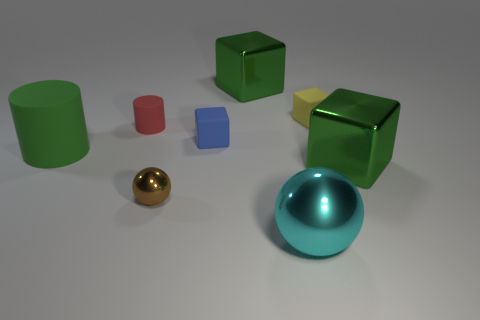There is a large green cube left of the big cube that is in front of the large green metallic object on the left side of the large sphere; what is its material?
Keep it short and to the point. Metal. There is a green cylinder; is its size the same as the green shiny thing in front of the small red object?
Offer a very short reply. Yes. What number of objects are either cyan balls in front of the red thing or green objects right of the tiny matte cylinder?
Your response must be concise. 3. What color is the metal block that is behind the small blue rubber cube?
Offer a very short reply. Green. Is there a tiny red matte thing that is behind the big green cube that is in front of the small cylinder?
Your response must be concise. Yes. Are there fewer large brown metal blocks than cyan metal spheres?
Ensure brevity in your answer.  Yes. There is a sphere to the right of the green cube on the left side of the yellow matte cube; what is its material?
Offer a very short reply. Metal. Is the size of the green cylinder the same as the brown thing?
Give a very brief answer. No. How many objects are either cyan balls or tiny brown matte cylinders?
Provide a short and direct response. 1. There is a object that is left of the large cyan metal thing and behind the small red object; what size is it?
Your answer should be very brief. Large. 